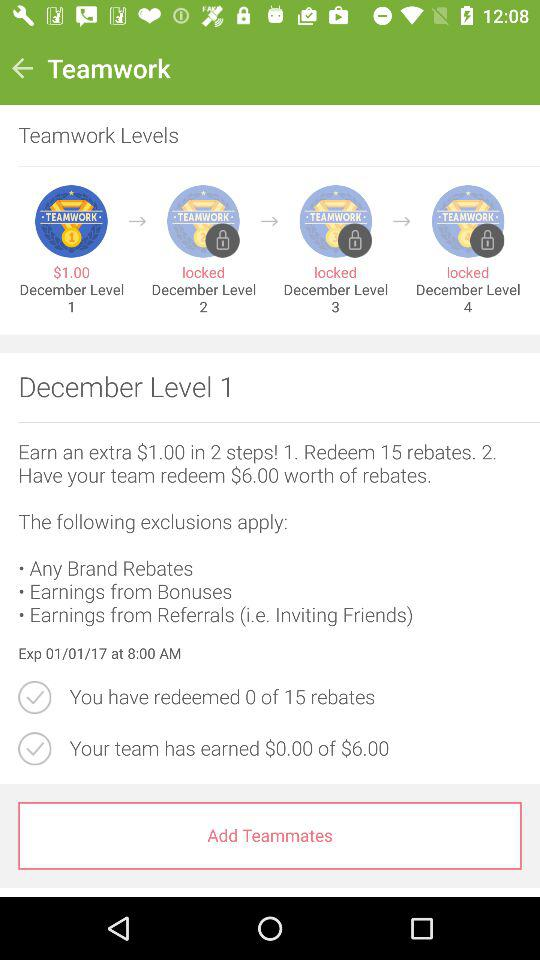How many teamwork levels are there?
Answer the question using a single word or phrase. 4 